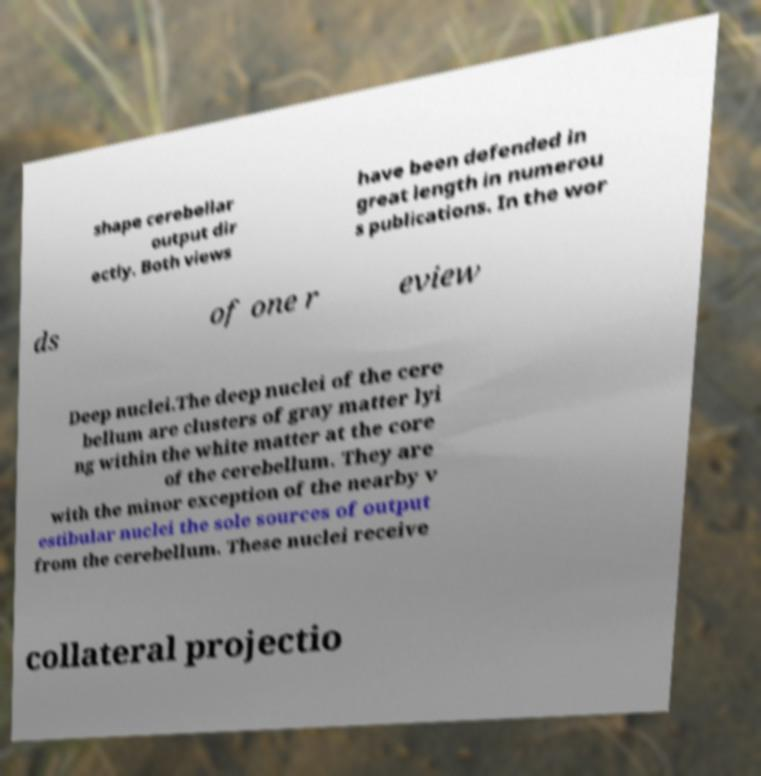Could you extract and type out the text from this image? shape cerebellar output dir ectly. Both views have been defended in great length in numerou s publications. In the wor ds of one r eview Deep nuclei.The deep nuclei of the cere bellum are clusters of gray matter lyi ng within the white matter at the core of the cerebellum. They are with the minor exception of the nearby v estibular nuclei the sole sources of output from the cerebellum. These nuclei receive collateral projectio 